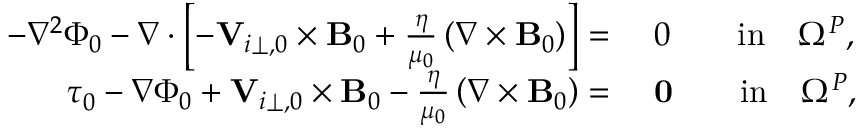Convert formula to latex. <formula><loc_0><loc_0><loc_500><loc_500>\begin{array} { r l } { - \nabla ^ { 2 } \Phi _ { 0 } - \nabla \cdot \left [ - { \mathbf V } _ { i \perp , 0 } \times { \mathbf B _ { 0 } } + \frac { \eta } { \mu _ { 0 } } \left ( \nabla \times { \mathbf B _ { 0 } } \right ) \right ] = } & { 0 \quad i n \quad \Omega ^ { P } , } \\ { \tau _ { 0 } - \nabla \Phi _ { 0 } + { \mathbf V } _ { i \perp , 0 } \times { \mathbf B _ { 0 } } - \frac { \eta } { \mu _ { 0 } } \left ( \nabla \times { \mathbf B _ { 0 } } \right ) = } & { 0 \quad i n \quad \Omega ^ { P } , } \end{array}</formula> 